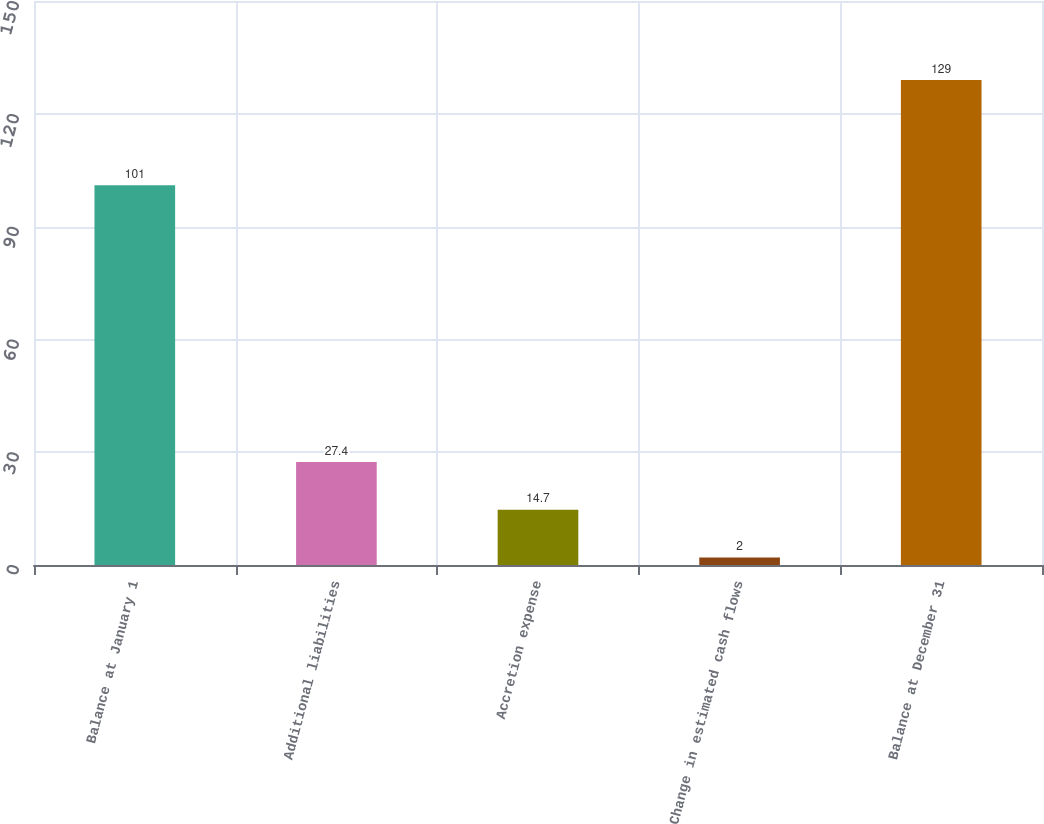Convert chart. <chart><loc_0><loc_0><loc_500><loc_500><bar_chart><fcel>Balance at January 1<fcel>Additional liabilities<fcel>Accretion expense<fcel>Change in estimated cash flows<fcel>Balance at December 31<nl><fcel>101<fcel>27.4<fcel>14.7<fcel>2<fcel>129<nl></chart> 